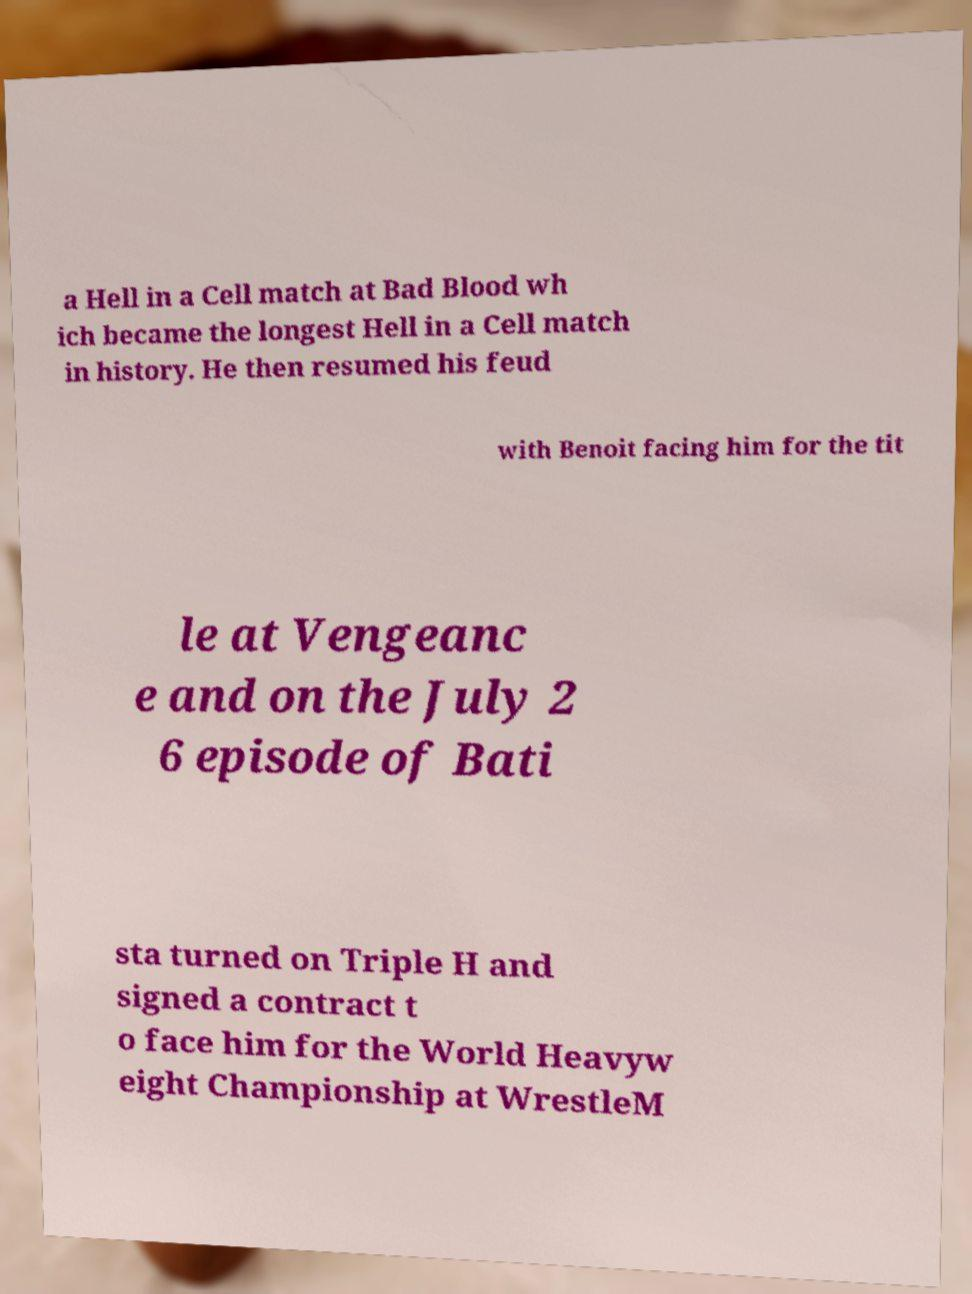Can you accurately transcribe the text from the provided image for me? a Hell in a Cell match at Bad Blood wh ich became the longest Hell in a Cell match in history. He then resumed his feud with Benoit facing him for the tit le at Vengeanc e and on the July 2 6 episode of Bati sta turned on Triple H and signed a contract t o face him for the World Heavyw eight Championship at WrestleM 